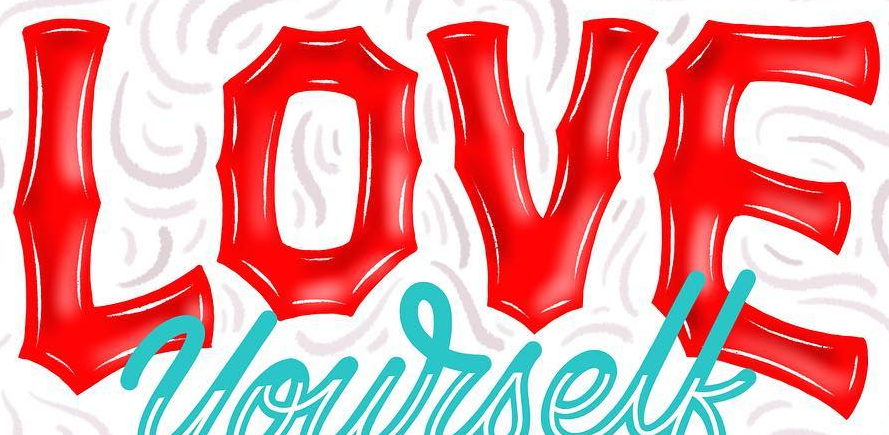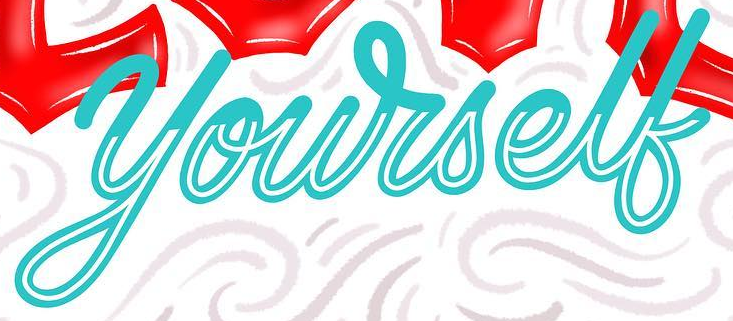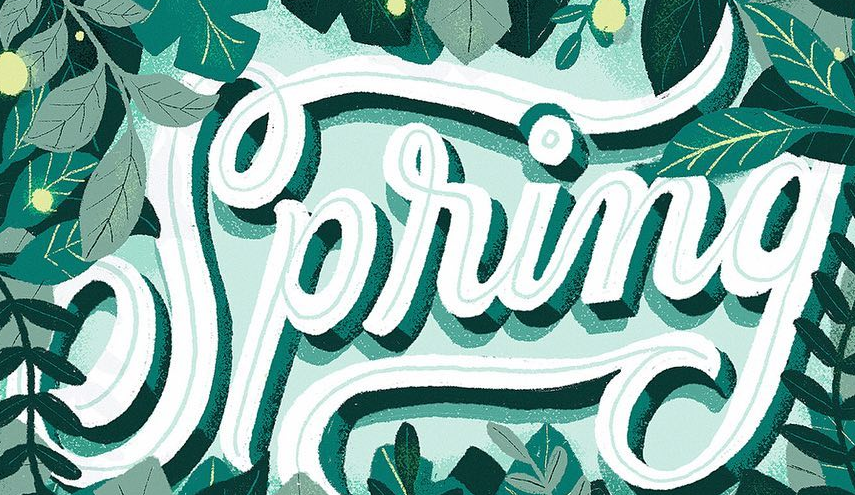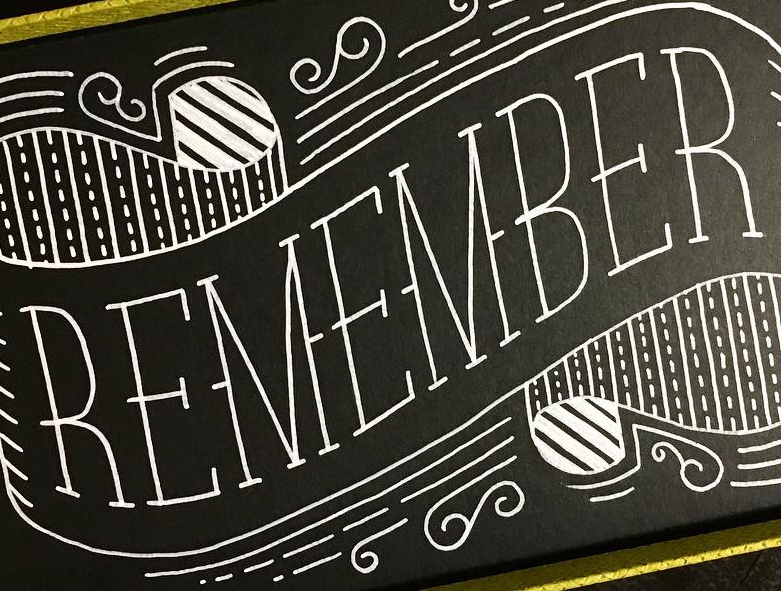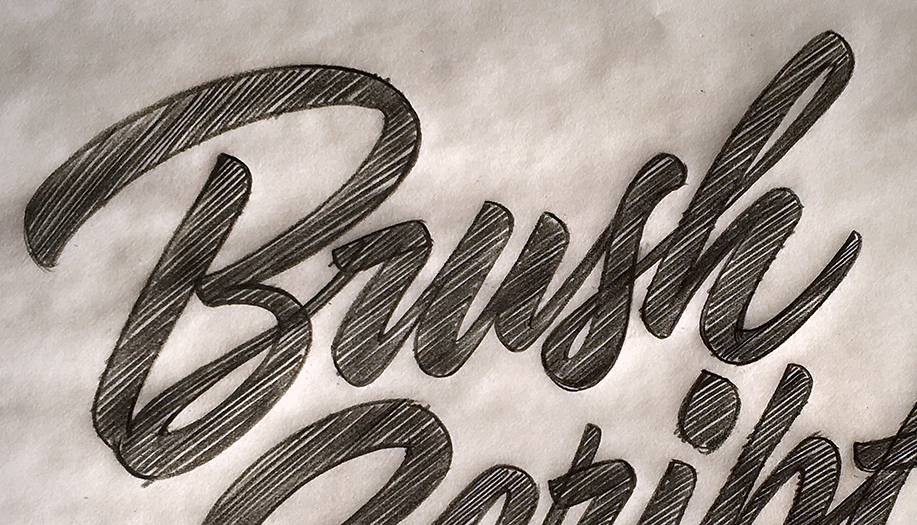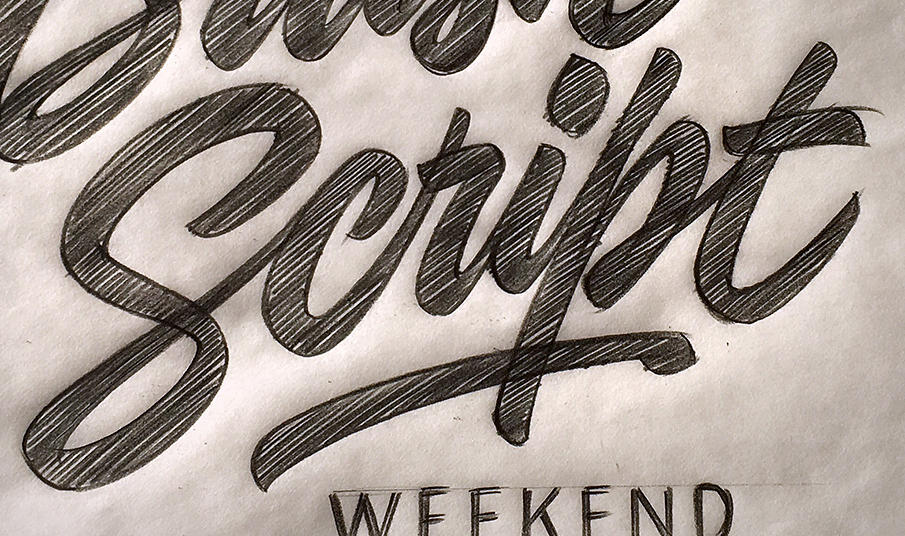What text is displayed in these images sequentially, separated by a semicolon? LOVE; yourself; Spring; REMEMBER; Brush; Script 